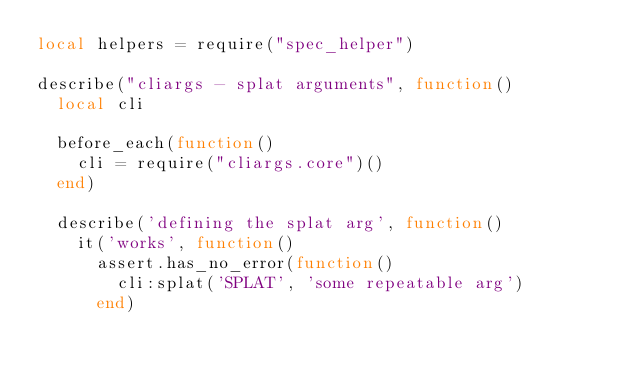Convert code to text. <code><loc_0><loc_0><loc_500><loc_500><_Lua_>local helpers = require("spec_helper")

describe("cliargs - splat arguments", function()
  local cli

  before_each(function()
    cli = require("cliargs.core")()
  end)

  describe('defining the splat arg', function()
    it('works', function()
      assert.has_no_error(function()
        cli:splat('SPLAT', 'some repeatable arg')
      end)</code> 